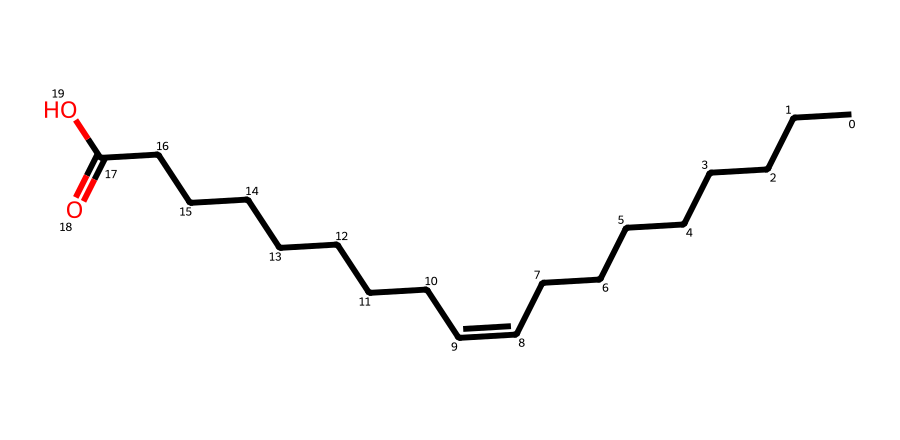What is the name of this chemical? The chemical structure represents oleic acid, which is derived from its typical long hydrocarbon chain and the presence of a carboxylic acid functional group (–COOH) at the end.
Answer: oleic acid How many carbon atoms are present in oleic acid? By analyzing the SMILES representation, there are 18 carbon atoms in total, as indicated by the long chain of "C" and the carbon that is part of the carboxyl group.
Answer: 18 What type of isomerism is exhibited by oleic acid? Oleic acid exhibits cis-trans isomerism due to the presence of a carbon-carbon double bond, allowing for different spatial arrangements of the atoms around that bond.
Answer: cis-trans What is the position of the double bond in oleic acid? The double bond in oleic acid is located between the 9th and 10th carbon atoms when counting from the carboxylic acid end, as indicated by the notation "/C=C\".
Answer: 9 and 10 What is the geometric configuration of oleic acid at the double bond? The configuration is cis, which indicates that the substituents (hydrogens) on the same side of the double bond lead to a bent shape of the molecule in this region.
Answer: cis 